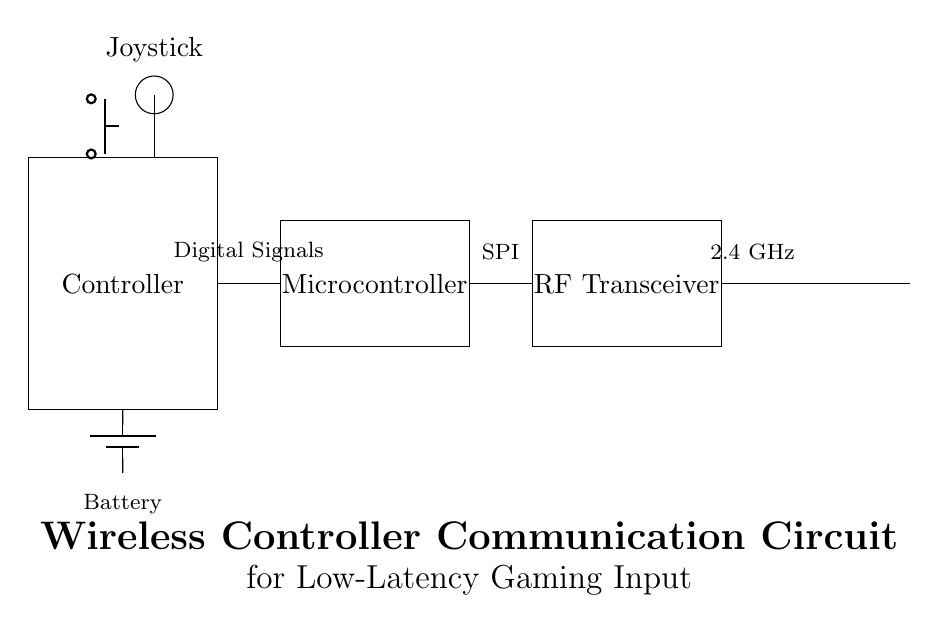What is the main function of the RF Transceiver? The RF Transceiver facilitates wireless communication by sending and receiving radio frequency signals, which is crucial for low-latency input transmission in gaming.
Answer: Wireless communication What type of signal does the Microcontroller handle? The Microcontroller processes digital signals from the controller and translates them into output that can be transmitted wirelessly.
Answer: Digital signals What component powers the circuit? The circuit is powered by a battery, indicated by the battery symbol in the diagram, which supplies the necessary voltage and current.
Answer: Battery What is the frequency of the RF Transceiver? The RF Transceiver operates at a frequency of 2.4 GHz, which is commonly used for wireless communication, particularly in gaming controllers.
Answer: 2.4 GHz How does the Joystick connect to the circuit? The Joystick connects to the Microcontroller via a direct wire, which allows the controller to send joystick movement data for processing and transmission.
Answer: Direct wire What is the purpose of the push button? The push button allows users to send a discrete control signal to the Microcontroller, typically for specific actions or commands in the game.
Answer: Control signal 